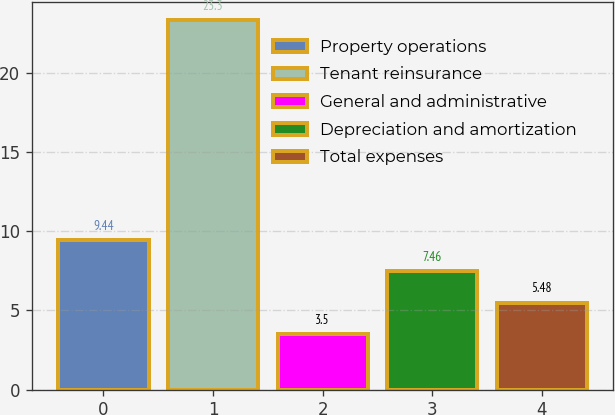Convert chart to OTSL. <chart><loc_0><loc_0><loc_500><loc_500><bar_chart><fcel>Property operations<fcel>Tenant reinsurance<fcel>General and administrative<fcel>Depreciation and amortization<fcel>Total expenses<nl><fcel>9.44<fcel>23.3<fcel>3.5<fcel>7.46<fcel>5.48<nl></chart> 